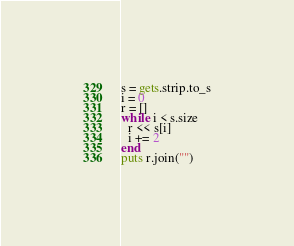<code> <loc_0><loc_0><loc_500><loc_500><_Ruby_>s = gets.strip.to_s
i = 0
r = []
while i < s.size
  r << s[i]
  i += 2
end
puts r.join("")</code> 